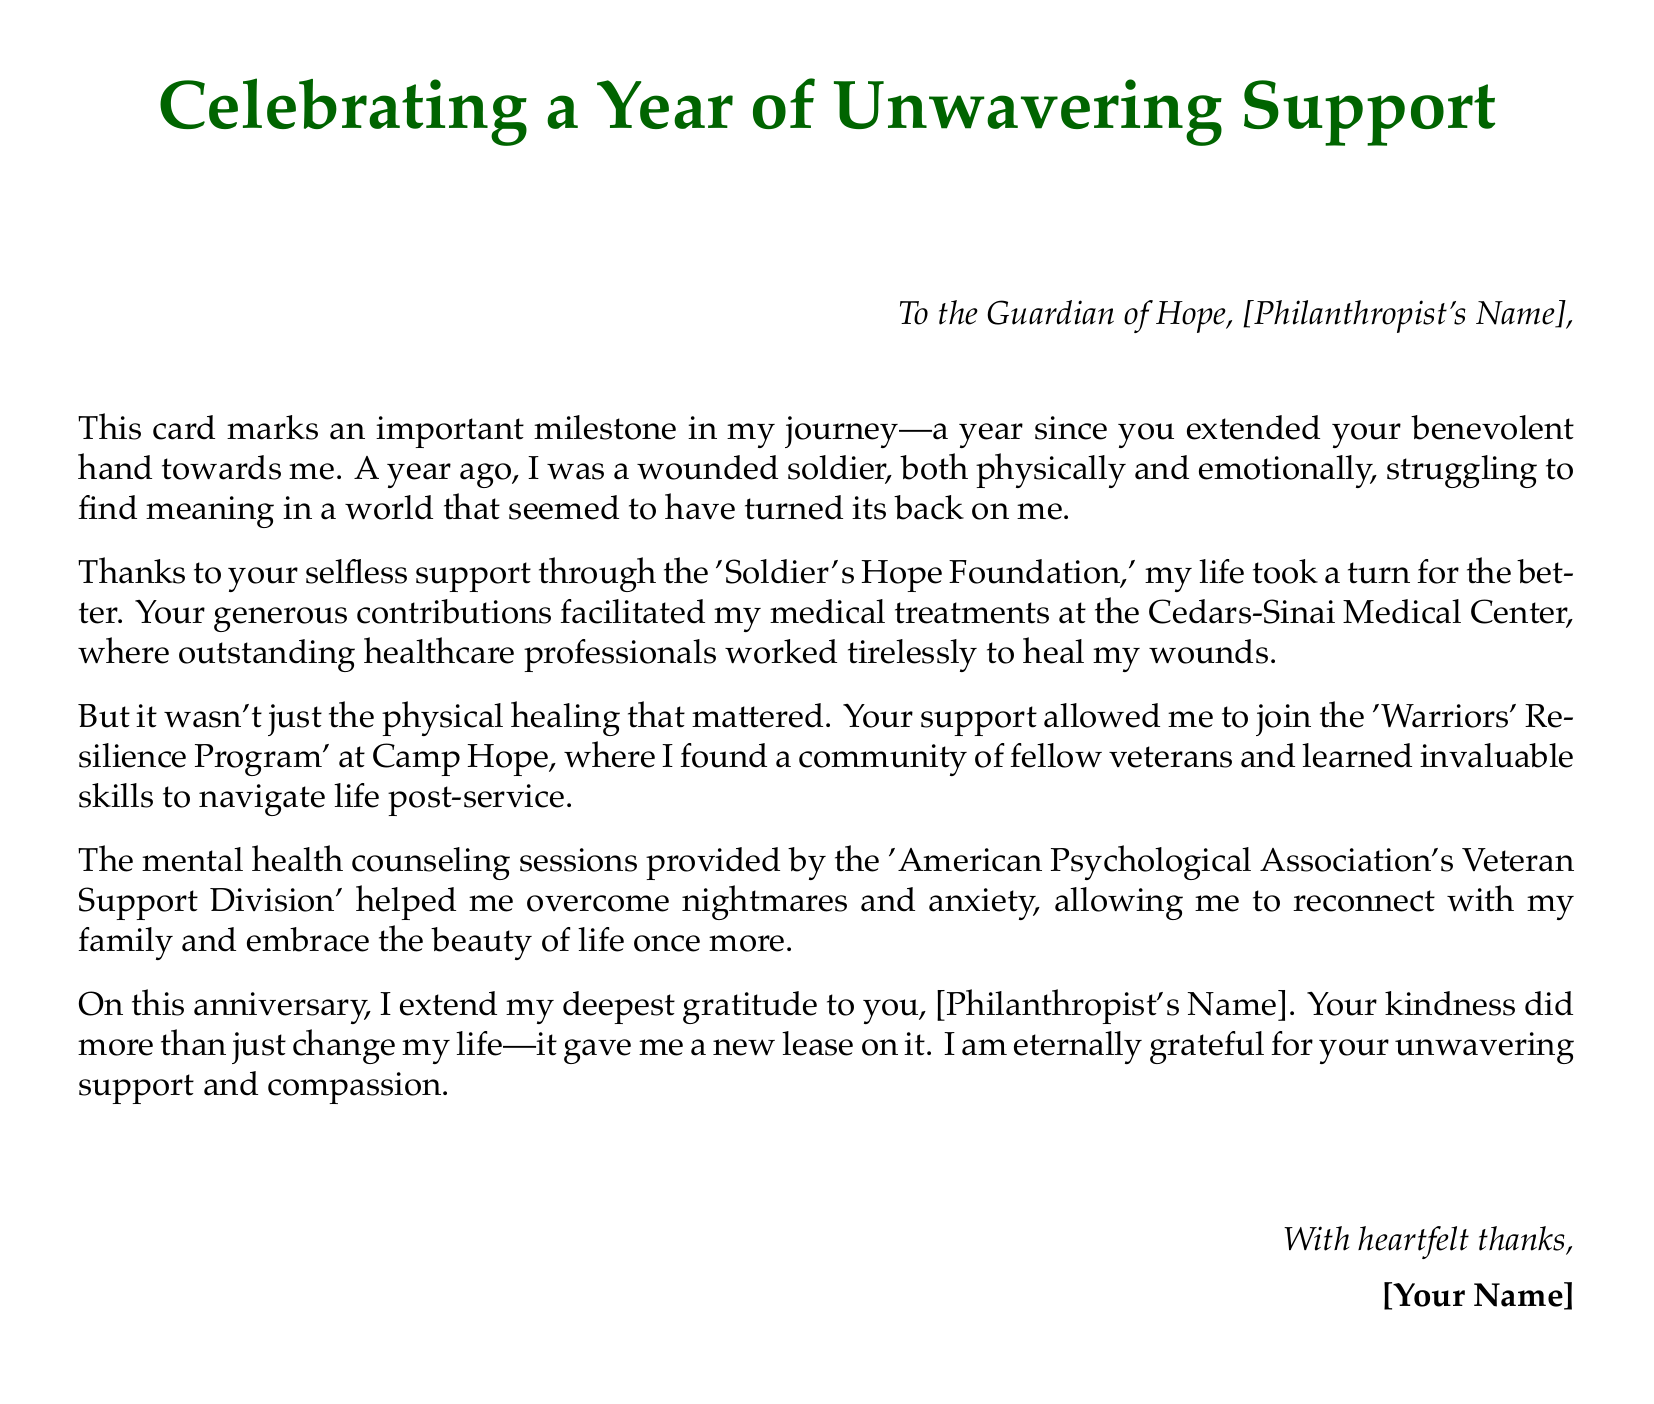What milestone is being celebrated? The document commemorates one year since the support was received from the philanthropist.
Answer: One year Who is the card addressed to? The card is addressed to the philanthropist, specifically referred to as "Guardian of Hope."
Answer: [Philanthropist's Name] What organization provided support for medical treatments? The medical treatments were facilitated by the 'Soldier's Hope Foundation.'
Answer: Soldier's Hope Foundation What program did the soldier join? The soldier joined the 'Warriors' Resilience Program' at Camp Hope.
Answer: Warriors' Resilience Program What type of counseling helped the soldier overcome anxiety? The counseling provided was through the 'American Psychological Association's Veteran Support Division.'
Answer: American Psychological Association's Veteran Support Division How does the soldier feel about the support received? The soldier expresses deep gratitude and acknowledges that the support gave him a new lease on life.
Answer: Gratitude What is the tone of the card? The tone of the card is heartfelt and appreciative.
Answer: Heartfelt What type of document is this? This document is a greeting card.
Answer: Greeting card 